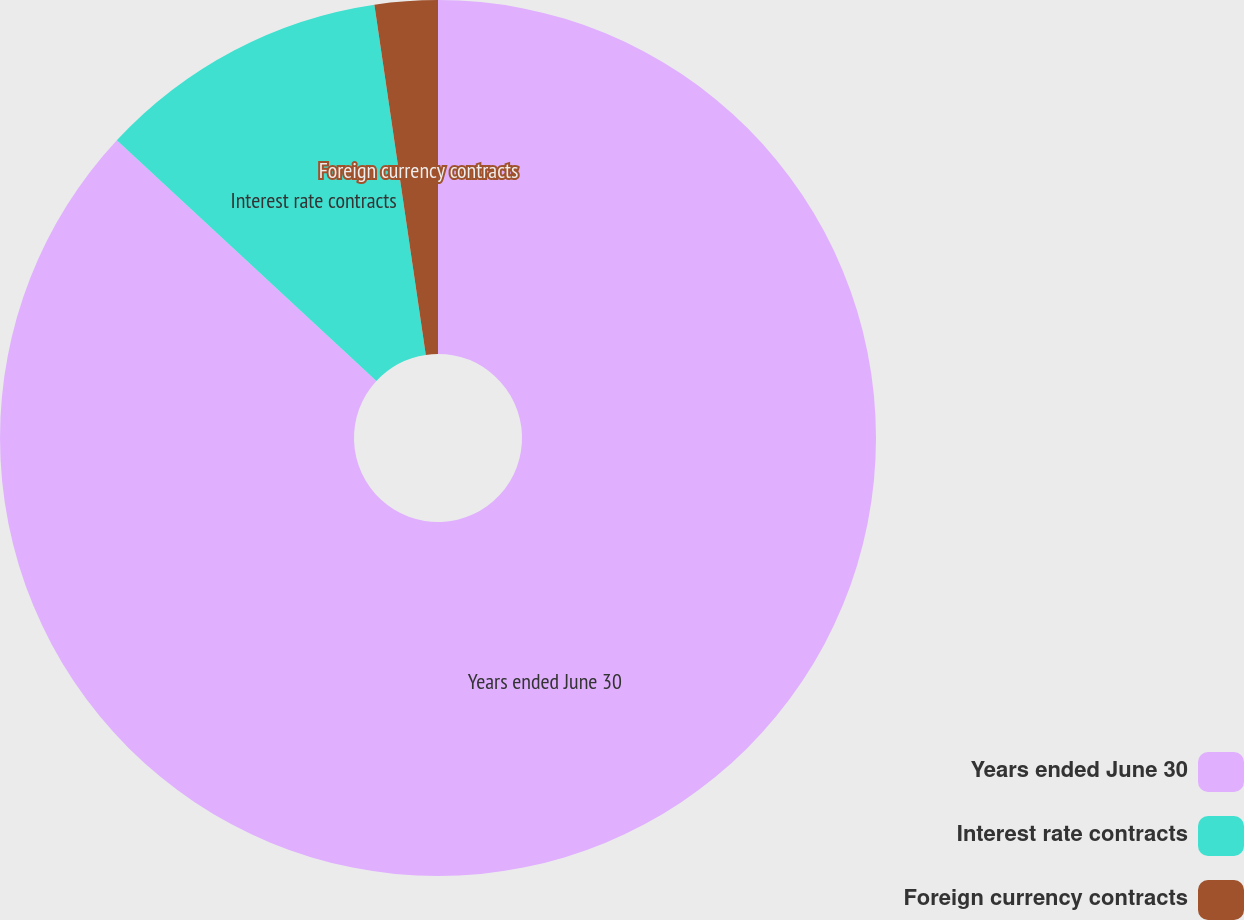Convert chart to OTSL. <chart><loc_0><loc_0><loc_500><loc_500><pie_chart><fcel>Years ended June 30<fcel>Interest rate contracts<fcel>Foreign currency contracts<nl><fcel>86.89%<fcel>10.78%<fcel>2.32%<nl></chart> 